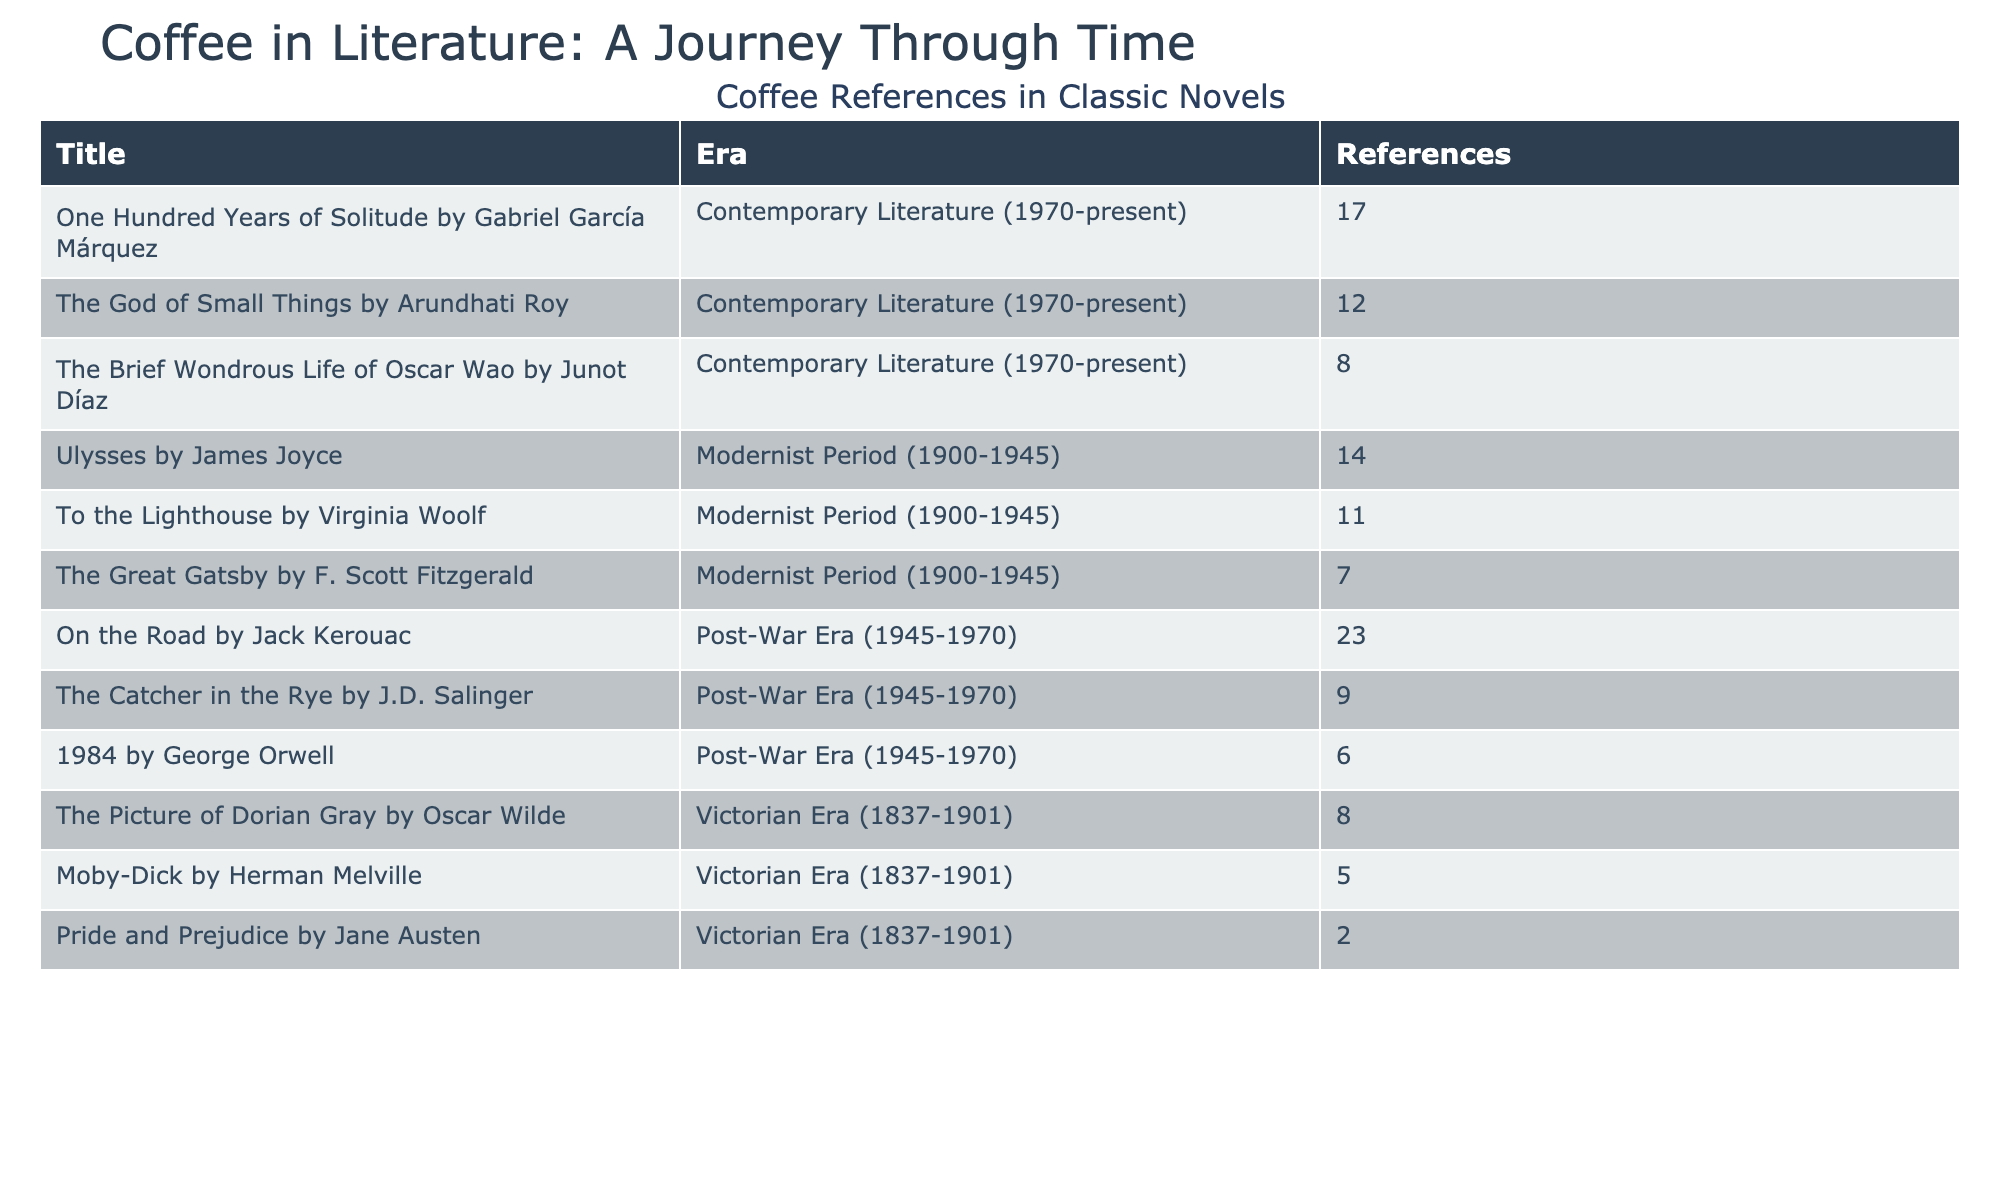What is the total number of coffee references in "Moby-Dick"? The table shows that "Moby-Dick" has 5 coffee references listed under the Victorian Era.
Answer: 5 Which novel has the highest number of coffee references in the Modernist Period? In the Modernist Period, "Ulysses" has 14 coffee references, which is the highest among the listed novels.
Answer: "Ulysses" How many coffee references does "The Great Gatsby" have compared to "To the Lighthouse"? "The Great Gatsby" has 7 coffee references while "To the Lighthouse" has 11. To compare, we subtract: 11 - 7 = 4.
Answer: 4 Which literary era contains the fewest coffee references across all novels? By observing the table, the Victorian Era has a total of 15 references (2 + 5 + 8) and the Modernist Period has 32 references (14 + 7 + 11), the Post-War Era has 38 references (6 + 9 + 23), and the Contemporary Literature has 37 references (17 + 12 + 8). The era with the least is the Victorian Era.
Answer: Victorian Era Is there any novel in the Contemporary Literature period that has more than 10 coffee references? By checking the table, "One Hundred Years of Solitude" has 17 references, "The God of Small Things" has 12, and "The Brief Wondrous Life of Oscar Wao" has 8. Thus, yes, there are novels with more than 10 references.
Answer: Yes What is the total number of coffee references across all novels in the Post-War Era? Adding the references in the Post-War Era: 6 (1984) + 9 (The Catcher in the Rye) + 23 (On the Road) = 38 references total.
Answer: 38 Which novel from the Victorian Era has the most coffee references? "The Picture of Dorian Gray" has 8 references, which is more than "Pride and Prejudice" (2) and "Moby-Dick" (5). Therefore, it is the novel with the most references.
Answer: "The Picture of Dorian Gray" How many more coffee references does "On the Road" have compared to "The Catcher in the Rye"? "On the Road" has 23 references and "The Catcher in the Rye" has 9 references. Subtracting: 23 - 9 = 14 indicates that it has 14 more references.
Answer: 14 During which literary period do we see the most diverse number of novels with coffee references? Observing the eras, the Modernist Period features 3 novels ("Ulysses," "The Great Gatsby," and "To the Lighthouse") while the Contemporary Literature has 3 ("One Hundred Years of Solitude," "The God of Small Things," and "The Brief Wondrous Life of Oscar Wao"). Therefore, both periods show equal diversity in terms of novels.
Answer: Both Modernist Period and Contemporary Literature What is the average number of coffee references for novels in the Victorian Era? In the Victorian Era, the novels and their references are "Pride and Prejudice" (2), "Moby-Dick" (5), and "The Picture of Dorian Gray" (8). The total sum is 2 + 5 + 8 = 15, and there are 3 novels, so the average is 15/3 = 5.
Answer: 5 